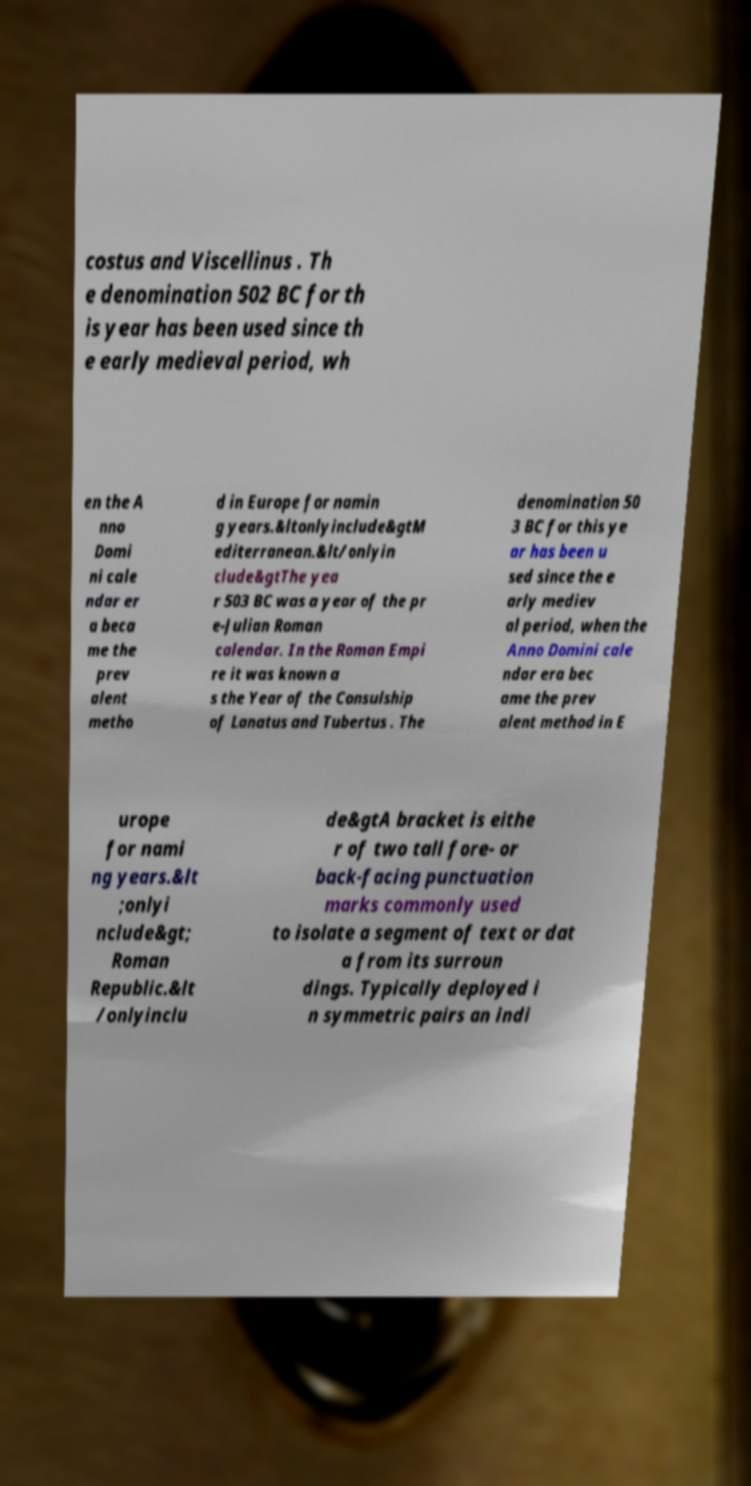For documentation purposes, I need the text within this image transcribed. Could you provide that? costus and Viscellinus . Th e denomination 502 BC for th is year has been used since th e early medieval period, wh en the A nno Domi ni cale ndar er a beca me the prev alent metho d in Europe for namin g years.&ltonlyinclude&gtM editerranean.&lt/onlyin clude&gtThe yea r 503 BC was a year of the pr e-Julian Roman calendar. In the Roman Empi re it was known a s the Year of the Consulship of Lanatus and Tubertus . The denomination 50 3 BC for this ye ar has been u sed since the e arly mediev al period, when the Anno Domini cale ndar era bec ame the prev alent method in E urope for nami ng years.&lt ;onlyi nclude&gt; Roman Republic.&lt /onlyinclu de&gtA bracket is eithe r of two tall fore- or back-facing punctuation marks commonly used to isolate a segment of text or dat a from its surroun dings. Typically deployed i n symmetric pairs an indi 